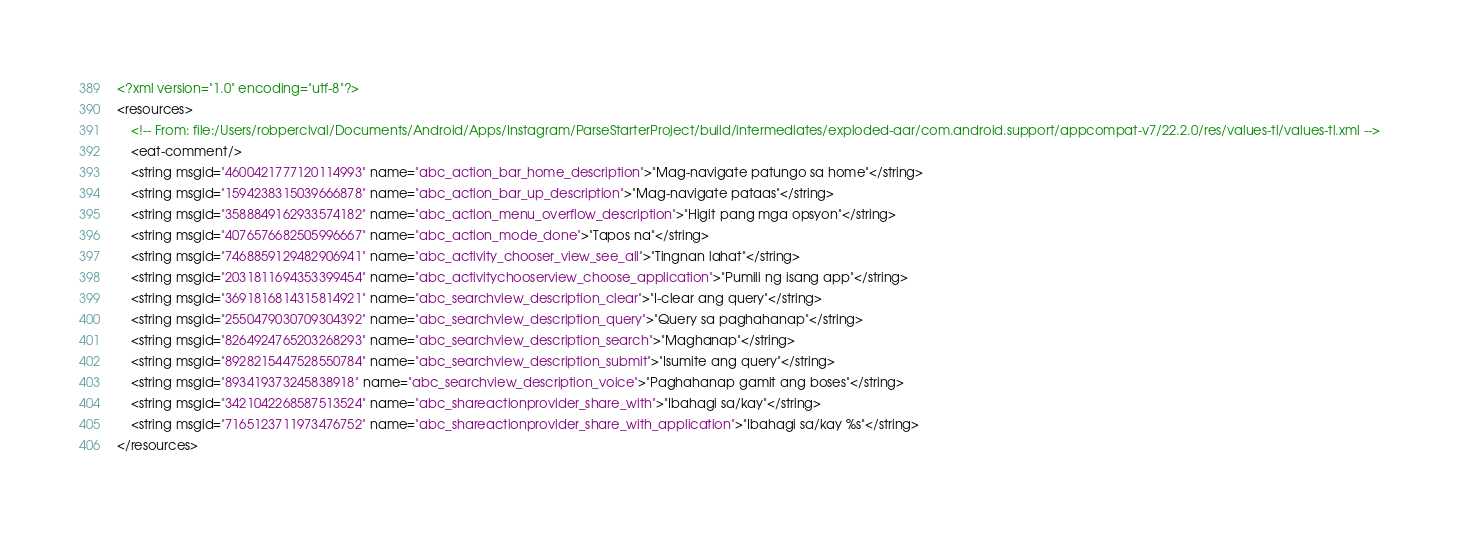Convert code to text. <code><loc_0><loc_0><loc_500><loc_500><_XML_><?xml version="1.0" encoding="utf-8"?>
<resources>
    <!-- From: file:/Users/robpercival/Documents/Android/Apps/Instagram/ParseStarterProject/build/intermediates/exploded-aar/com.android.support/appcompat-v7/22.2.0/res/values-tl/values-tl.xml -->
    <eat-comment/>
    <string msgid="4600421777120114993" name="abc_action_bar_home_description">"Mag-navigate patungo sa home"</string>
    <string msgid="1594238315039666878" name="abc_action_bar_up_description">"Mag-navigate pataas"</string>
    <string msgid="3588849162933574182" name="abc_action_menu_overflow_description">"Higit pang mga opsyon"</string>
    <string msgid="4076576682505996667" name="abc_action_mode_done">"Tapos na"</string>
    <string msgid="7468859129482906941" name="abc_activity_chooser_view_see_all">"Tingnan lahat"</string>
    <string msgid="2031811694353399454" name="abc_activitychooserview_choose_application">"Pumili ng isang app"</string>
    <string msgid="3691816814315814921" name="abc_searchview_description_clear">"I-clear ang query"</string>
    <string msgid="2550479030709304392" name="abc_searchview_description_query">"Query sa paghahanap"</string>
    <string msgid="8264924765203268293" name="abc_searchview_description_search">"Maghanap"</string>
    <string msgid="8928215447528550784" name="abc_searchview_description_submit">"Isumite ang query"</string>
    <string msgid="893419373245838918" name="abc_searchview_description_voice">"Paghahanap gamit ang boses"</string>
    <string msgid="3421042268587513524" name="abc_shareactionprovider_share_with">"Ibahagi sa/kay"</string>
    <string msgid="7165123711973476752" name="abc_shareactionprovider_share_with_application">"Ibahagi sa/kay %s"</string>
</resources></code> 